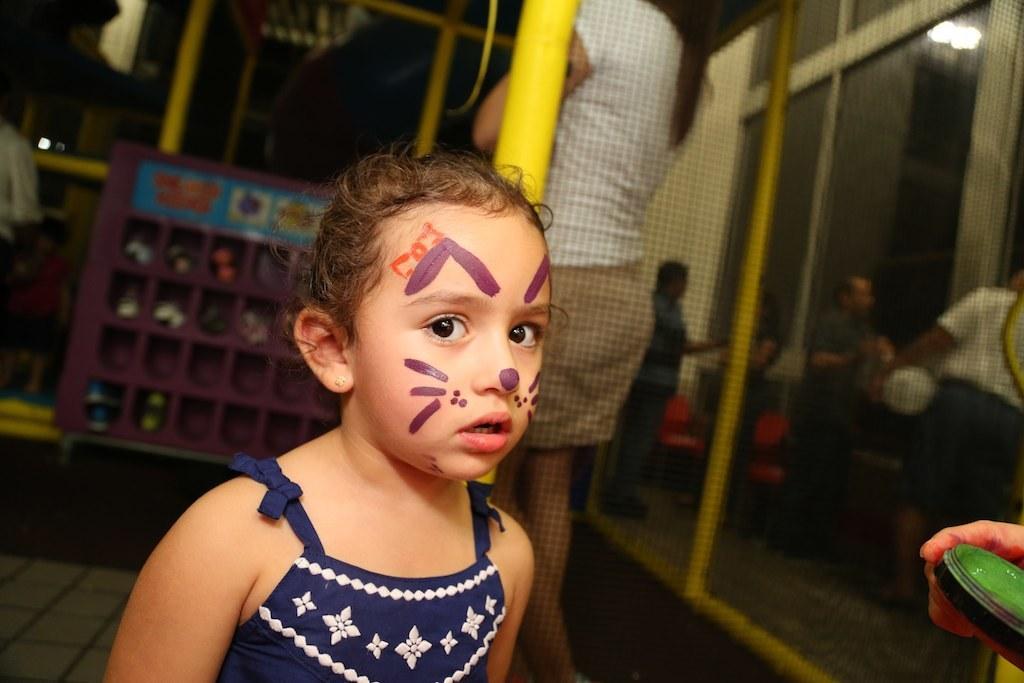Can you describe this image briefly? In this image in the foreground there is one girl, and in the background there are some persons standing and also we could see some objects, boards, chairs, poles, net and at the bottom there is a floor. 